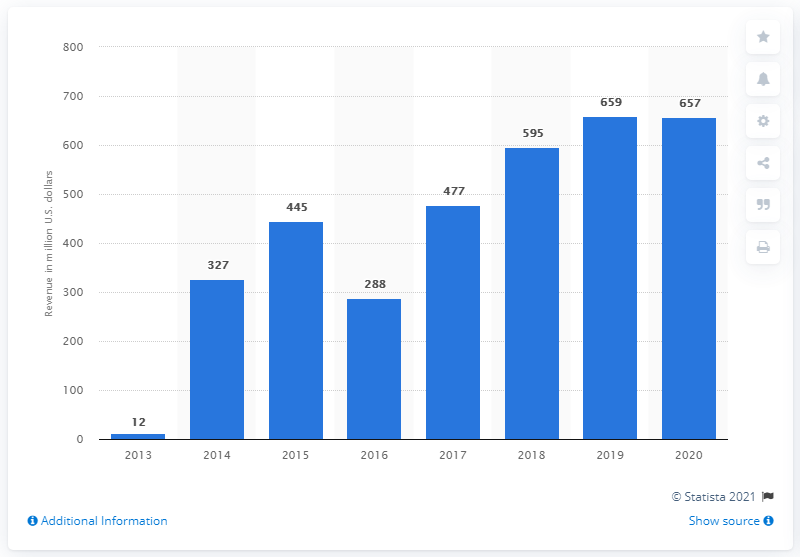Outline some significant characteristics in this image. Alphabet's Other Bets segment generated approximately 657 million in revenue in the prior fiscal year. 